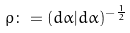Convert formula to latex. <formula><loc_0><loc_0><loc_500><loc_500>\rho \colon = ( d \alpha | d \alpha ) ^ { - \frac { 1 } { 2 } }</formula> 